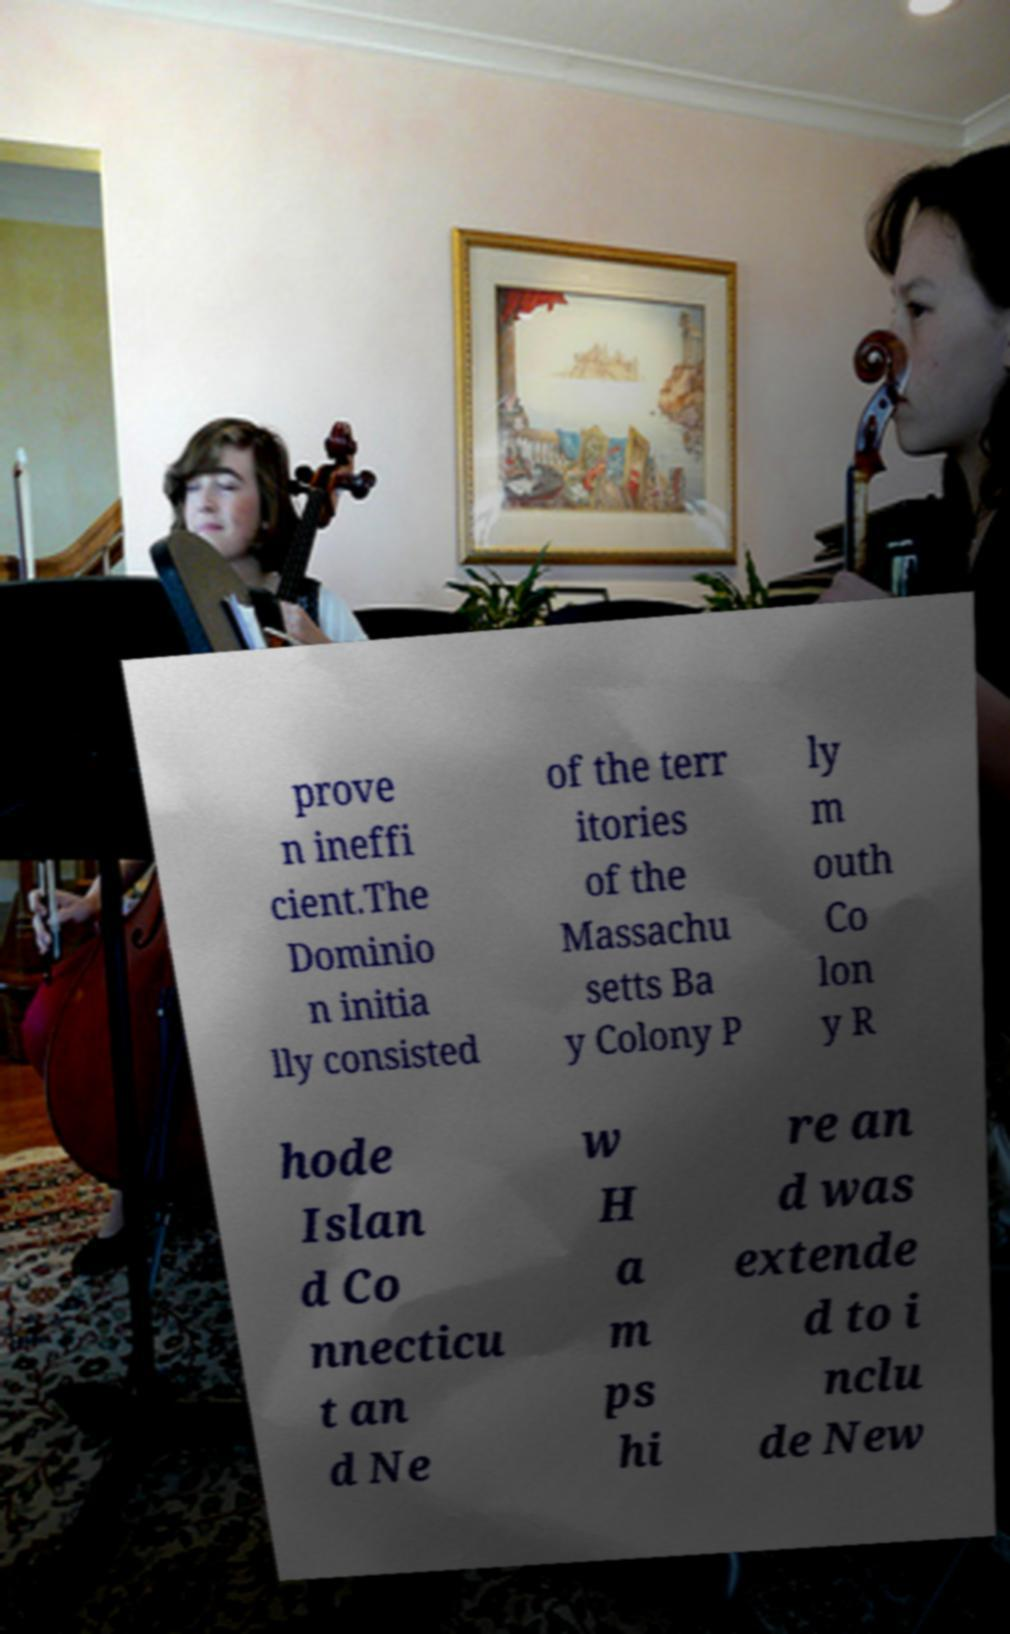For documentation purposes, I need the text within this image transcribed. Could you provide that? prove n ineffi cient.The Dominio n initia lly consisted of the terr itories of the Massachu setts Ba y Colony P ly m outh Co lon y R hode Islan d Co nnecticu t an d Ne w H a m ps hi re an d was extende d to i nclu de New 